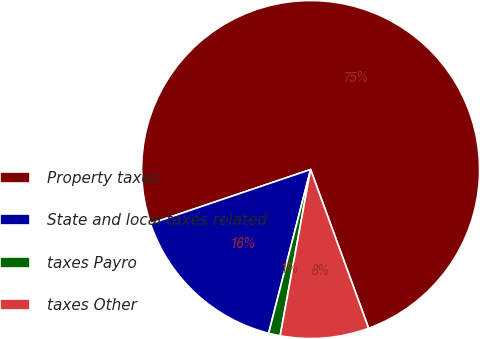Convert chart. <chart><loc_0><loc_0><loc_500><loc_500><pie_chart><fcel>Property taxes<fcel>State and local taxes related<fcel>taxes Payro<fcel>taxes Other<nl><fcel>74.61%<fcel>15.81%<fcel>1.11%<fcel>8.46%<nl></chart> 